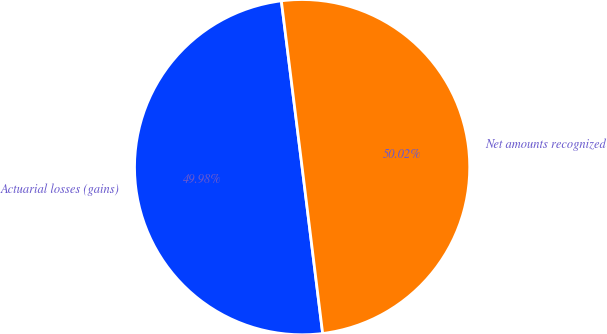<chart> <loc_0><loc_0><loc_500><loc_500><pie_chart><fcel>Actuarial losses (gains)<fcel>Net amounts recognized<nl><fcel>49.98%<fcel>50.02%<nl></chart> 